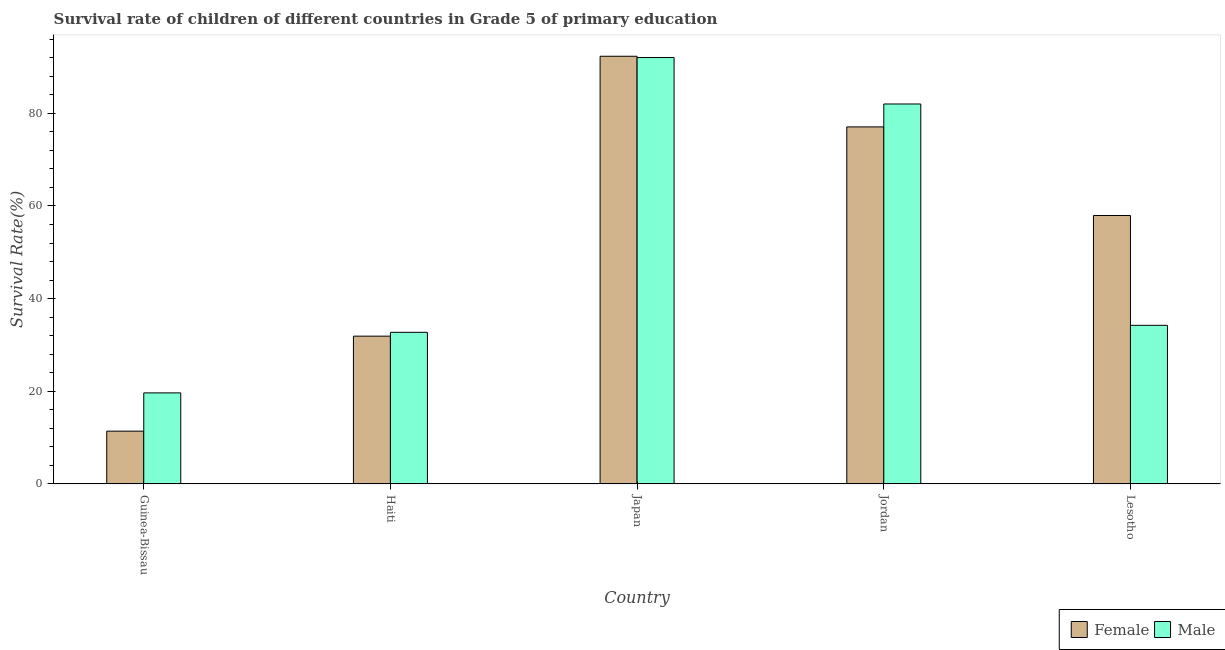How many groups of bars are there?
Your response must be concise. 5. Are the number of bars per tick equal to the number of legend labels?
Your answer should be compact. Yes. How many bars are there on the 3rd tick from the left?
Your response must be concise. 2. How many bars are there on the 1st tick from the right?
Give a very brief answer. 2. What is the label of the 4th group of bars from the left?
Offer a very short reply. Jordan. What is the survival rate of male students in primary education in Lesotho?
Your answer should be very brief. 34.24. Across all countries, what is the maximum survival rate of male students in primary education?
Provide a short and direct response. 92.03. Across all countries, what is the minimum survival rate of male students in primary education?
Keep it short and to the point. 19.66. In which country was the survival rate of female students in primary education minimum?
Offer a terse response. Guinea-Bissau. What is the total survival rate of male students in primary education in the graph?
Your answer should be compact. 260.67. What is the difference between the survival rate of male students in primary education in Jordan and that in Lesotho?
Your answer should be very brief. 47.77. What is the difference between the survival rate of male students in primary education in Haiti and the survival rate of female students in primary education in Jordan?
Offer a very short reply. -44.33. What is the average survival rate of female students in primary education per country?
Provide a short and direct response. 54.12. What is the difference between the survival rate of female students in primary education and survival rate of male students in primary education in Japan?
Provide a succinct answer. 0.28. What is the ratio of the survival rate of male students in primary education in Guinea-Bissau to that in Haiti?
Your answer should be very brief. 0.6. Is the survival rate of female students in primary education in Haiti less than that in Jordan?
Provide a succinct answer. Yes. What is the difference between the highest and the second highest survival rate of female students in primary education?
Ensure brevity in your answer.  15.25. What is the difference between the highest and the lowest survival rate of female students in primary education?
Your answer should be compact. 80.91. Is the sum of the survival rate of female students in primary education in Haiti and Jordan greater than the maximum survival rate of male students in primary education across all countries?
Your response must be concise. Yes. What does the 1st bar from the left in Jordan represents?
Your response must be concise. Female. How many bars are there?
Ensure brevity in your answer.  10. Are all the bars in the graph horizontal?
Your response must be concise. No. How many countries are there in the graph?
Make the answer very short. 5. Does the graph contain any zero values?
Your answer should be compact. No. Does the graph contain grids?
Provide a succinct answer. No. How many legend labels are there?
Offer a very short reply. 2. What is the title of the graph?
Offer a very short reply. Survival rate of children of different countries in Grade 5 of primary education. Does "Non-resident workers" appear as one of the legend labels in the graph?
Your answer should be very brief. No. What is the label or title of the X-axis?
Keep it short and to the point. Country. What is the label or title of the Y-axis?
Your answer should be very brief. Survival Rate(%). What is the Survival Rate(%) in Female in Guinea-Bissau?
Give a very brief answer. 11.4. What is the Survival Rate(%) of Male in Guinea-Bissau?
Give a very brief answer. 19.66. What is the Survival Rate(%) in Female in Haiti?
Offer a terse response. 31.9. What is the Survival Rate(%) of Male in Haiti?
Your response must be concise. 32.73. What is the Survival Rate(%) of Female in Japan?
Give a very brief answer. 92.31. What is the Survival Rate(%) in Male in Japan?
Give a very brief answer. 92.03. What is the Survival Rate(%) of Female in Jordan?
Your response must be concise. 77.06. What is the Survival Rate(%) of Male in Jordan?
Give a very brief answer. 82.01. What is the Survival Rate(%) of Female in Lesotho?
Offer a terse response. 57.94. What is the Survival Rate(%) of Male in Lesotho?
Provide a short and direct response. 34.24. Across all countries, what is the maximum Survival Rate(%) in Female?
Your answer should be compact. 92.31. Across all countries, what is the maximum Survival Rate(%) in Male?
Provide a succinct answer. 92.03. Across all countries, what is the minimum Survival Rate(%) in Female?
Make the answer very short. 11.4. Across all countries, what is the minimum Survival Rate(%) in Male?
Provide a short and direct response. 19.66. What is the total Survival Rate(%) of Female in the graph?
Make the answer very short. 270.62. What is the total Survival Rate(%) of Male in the graph?
Make the answer very short. 260.67. What is the difference between the Survival Rate(%) in Female in Guinea-Bissau and that in Haiti?
Give a very brief answer. -20.5. What is the difference between the Survival Rate(%) of Male in Guinea-Bissau and that in Haiti?
Your response must be concise. -13.07. What is the difference between the Survival Rate(%) of Female in Guinea-Bissau and that in Japan?
Keep it short and to the point. -80.91. What is the difference between the Survival Rate(%) of Male in Guinea-Bissau and that in Japan?
Make the answer very short. -72.37. What is the difference between the Survival Rate(%) of Female in Guinea-Bissau and that in Jordan?
Keep it short and to the point. -65.66. What is the difference between the Survival Rate(%) of Male in Guinea-Bissau and that in Jordan?
Give a very brief answer. -62.35. What is the difference between the Survival Rate(%) in Female in Guinea-Bissau and that in Lesotho?
Provide a succinct answer. -46.54. What is the difference between the Survival Rate(%) of Male in Guinea-Bissau and that in Lesotho?
Give a very brief answer. -14.58. What is the difference between the Survival Rate(%) of Female in Haiti and that in Japan?
Provide a short and direct response. -60.41. What is the difference between the Survival Rate(%) in Male in Haiti and that in Japan?
Provide a succinct answer. -59.3. What is the difference between the Survival Rate(%) of Female in Haiti and that in Jordan?
Your response must be concise. -45.16. What is the difference between the Survival Rate(%) in Male in Haiti and that in Jordan?
Your answer should be compact. -49.28. What is the difference between the Survival Rate(%) in Female in Haiti and that in Lesotho?
Your answer should be very brief. -26.04. What is the difference between the Survival Rate(%) in Male in Haiti and that in Lesotho?
Give a very brief answer. -1.51. What is the difference between the Survival Rate(%) in Female in Japan and that in Jordan?
Provide a short and direct response. 15.25. What is the difference between the Survival Rate(%) of Male in Japan and that in Jordan?
Provide a short and direct response. 10.02. What is the difference between the Survival Rate(%) in Female in Japan and that in Lesotho?
Provide a succinct answer. 34.37. What is the difference between the Survival Rate(%) of Male in Japan and that in Lesotho?
Provide a succinct answer. 57.79. What is the difference between the Survival Rate(%) in Female in Jordan and that in Lesotho?
Your response must be concise. 19.12. What is the difference between the Survival Rate(%) in Male in Jordan and that in Lesotho?
Offer a very short reply. 47.77. What is the difference between the Survival Rate(%) in Female in Guinea-Bissau and the Survival Rate(%) in Male in Haiti?
Make the answer very short. -21.33. What is the difference between the Survival Rate(%) in Female in Guinea-Bissau and the Survival Rate(%) in Male in Japan?
Provide a short and direct response. -80.63. What is the difference between the Survival Rate(%) in Female in Guinea-Bissau and the Survival Rate(%) in Male in Jordan?
Offer a very short reply. -70.6. What is the difference between the Survival Rate(%) of Female in Guinea-Bissau and the Survival Rate(%) of Male in Lesotho?
Make the answer very short. -22.84. What is the difference between the Survival Rate(%) in Female in Haiti and the Survival Rate(%) in Male in Japan?
Provide a succinct answer. -60.13. What is the difference between the Survival Rate(%) in Female in Haiti and the Survival Rate(%) in Male in Jordan?
Give a very brief answer. -50.1. What is the difference between the Survival Rate(%) in Female in Haiti and the Survival Rate(%) in Male in Lesotho?
Keep it short and to the point. -2.34. What is the difference between the Survival Rate(%) of Female in Japan and the Survival Rate(%) of Male in Jordan?
Provide a succinct answer. 10.3. What is the difference between the Survival Rate(%) of Female in Japan and the Survival Rate(%) of Male in Lesotho?
Your answer should be compact. 58.07. What is the difference between the Survival Rate(%) in Female in Jordan and the Survival Rate(%) in Male in Lesotho?
Provide a succinct answer. 42.82. What is the average Survival Rate(%) of Female per country?
Offer a very short reply. 54.12. What is the average Survival Rate(%) of Male per country?
Your answer should be very brief. 52.13. What is the difference between the Survival Rate(%) of Female and Survival Rate(%) of Male in Guinea-Bissau?
Your response must be concise. -8.26. What is the difference between the Survival Rate(%) in Female and Survival Rate(%) in Male in Haiti?
Give a very brief answer. -0.83. What is the difference between the Survival Rate(%) of Female and Survival Rate(%) of Male in Japan?
Make the answer very short. 0.28. What is the difference between the Survival Rate(%) of Female and Survival Rate(%) of Male in Jordan?
Offer a very short reply. -4.95. What is the difference between the Survival Rate(%) in Female and Survival Rate(%) in Male in Lesotho?
Your answer should be very brief. 23.7. What is the ratio of the Survival Rate(%) in Female in Guinea-Bissau to that in Haiti?
Keep it short and to the point. 0.36. What is the ratio of the Survival Rate(%) of Male in Guinea-Bissau to that in Haiti?
Your response must be concise. 0.6. What is the ratio of the Survival Rate(%) of Female in Guinea-Bissau to that in Japan?
Provide a succinct answer. 0.12. What is the ratio of the Survival Rate(%) in Male in Guinea-Bissau to that in Japan?
Your answer should be very brief. 0.21. What is the ratio of the Survival Rate(%) in Female in Guinea-Bissau to that in Jordan?
Your response must be concise. 0.15. What is the ratio of the Survival Rate(%) of Male in Guinea-Bissau to that in Jordan?
Make the answer very short. 0.24. What is the ratio of the Survival Rate(%) in Female in Guinea-Bissau to that in Lesotho?
Provide a short and direct response. 0.2. What is the ratio of the Survival Rate(%) of Male in Guinea-Bissau to that in Lesotho?
Ensure brevity in your answer.  0.57. What is the ratio of the Survival Rate(%) of Female in Haiti to that in Japan?
Provide a succinct answer. 0.35. What is the ratio of the Survival Rate(%) of Male in Haiti to that in Japan?
Your answer should be compact. 0.36. What is the ratio of the Survival Rate(%) of Female in Haiti to that in Jordan?
Offer a terse response. 0.41. What is the ratio of the Survival Rate(%) in Male in Haiti to that in Jordan?
Keep it short and to the point. 0.4. What is the ratio of the Survival Rate(%) in Female in Haiti to that in Lesotho?
Provide a succinct answer. 0.55. What is the ratio of the Survival Rate(%) in Male in Haiti to that in Lesotho?
Keep it short and to the point. 0.96. What is the ratio of the Survival Rate(%) in Female in Japan to that in Jordan?
Ensure brevity in your answer.  1.2. What is the ratio of the Survival Rate(%) of Male in Japan to that in Jordan?
Provide a succinct answer. 1.12. What is the ratio of the Survival Rate(%) of Female in Japan to that in Lesotho?
Ensure brevity in your answer.  1.59. What is the ratio of the Survival Rate(%) of Male in Japan to that in Lesotho?
Provide a succinct answer. 2.69. What is the ratio of the Survival Rate(%) of Female in Jordan to that in Lesotho?
Your answer should be very brief. 1.33. What is the ratio of the Survival Rate(%) in Male in Jordan to that in Lesotho?
Your response must be concise. 2.4. What is the difference between the highest and the second highest Survival Rate(%) in Female?
Your response must be concise. 15.25. What is the difference between the highest and the second highest Survival Rate(%) of Male?
Your answer should be very brief. 10.02. What is the difference between the highest and the lowest Survival Rate(%) in Female?
Make the answer very short. 80.91. What is the difference between the highest and the lowest Survival Rate(%) of Male?
Offer a terse response. 72.37. 